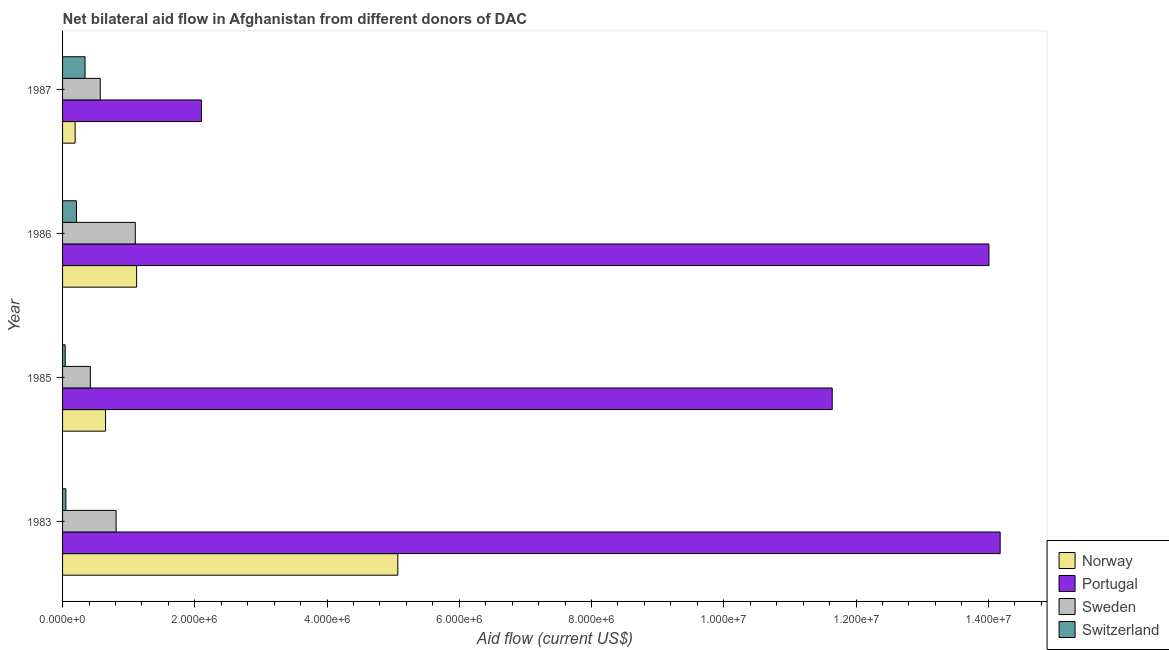How many groups of bars are there?
Provide a succinct answer. 4. Are the number of bars per tick equal to the number of legend labels?
Give a very brief answer. Yes. How many bars are there on the 4th tick from the bottom?
Your response must be concise. 4. What is the label of the 2nd group of bars from the top?
Your answer should be compact. 1986. What is the amount of aid given by sweden in 1983?
Provide a succinct answer. 8.10e+05. Across all years, what is the maximum amount of aid given by switzerland?
Offer a terse response. 3.40e+05. Across all years, what is the minimum amount of aid given by switzerland?
Offer a terse response. 4.00e+04. What is the total amount of aid given by portugal in the graph?
Give a very brief answer. 4.19e+07. What is the difference between the amount of aid given by portugal in 1985 and that in 1986?
Provide a short and direct response. -2.37e+06. What is the difference between the amount of aid given by sweden in 1985 and the amount of aid given by norway in 1986?
Ensure brevity in your answer.  -7.00e+05. What is the average amount of aid given by sweden per year?
Offer a very short reply. 7.25e+05. In the year 1985, what is the difference between the amount of aid given by norway and amount of aid given by switzerland?
Provide a succinct answer. 6.10e+05. In how many years, is the amount of aid given by portugal greater than 2400000 US$?
Offer a very short reply. 3. What is the ratio of the amount of aid given by portugal in 1985 to that in 1987?
Provide a succinct answer. 5.54. What is the difference between the highest and the second highest amount of aid given by portugal?
Provide a succinct answer. 1.70e+05. What is the difference between the highest and the lowest amount of aid given by sweden?
Provide a short and direct response. 6.80e+05. In how many years, is the amount of aid given by sweden greater than the average amount of aid given by sweden taken over all years?
Make the answer very short. 2. Is the sum of the amount of aid given by switzerland in 1985 and 1987 greater than the maximum amount of aid given by portugal across all years?
Provide a short and direct response. No. What does the 1st bar from the top in 1987 represents?
Offer a very short reply. Switzerland. What does the 1st bar from the bottom in 1983 represents?
Ensure brevity in your answer.  Norway. Is it the case that in every year, the sum of the amount of aid given by norway and amount of aid given by portugal is greater than the amount of aid given by sweden?
Offer a terse response. Yes. How many bars are there?
Provide a short and direct response. 16. How many years are there in the graph?
Provide a succinct answer. 4. What is the difference between two consecutive major ticks on the X-axis?
Provide a succinct answer. 2.00e+06. Where does the legend appear in the graph?
Your response must be concise. Bottom right. What is the title of the graph?
Ensure brevity in your answer.  Net bilateral aid flow in Afghanistan from different donors of DAC. What is the label or title of the X-axis?
Give a very brief answer. Aid flow (current US$). What is the Aid flow (current US$) in Norway in 1983?
Make the answer very short. 5.07e+06. What is the Aid flow (current US$) in Portugal in 1983?
Offer a very short reply. 1.42e+07. What is the Aid flow (current US$) of Sweden in 1983?
Your answer should be compact. 8.10e+05. What is the Aid flow (current US$) in Norway in 1985?
Provide a short and direct response. 6.50e+05. What is the Aid flow (current US$) of Portugal in 1985?
Offer a terse response. 1.16e+07. What is the Aid flow (current US$) in Sweden in 1985?
Make the answer very short. 4.20e+05. What is the Aid flow (current US$) in Norway in 1986?
Make the answer very short. 1.12e+06. What is the Aid flow (current US$) of Portugal in 1986?
Ensure brevity in your answer.  1.40e+07. What is the Aid flow (current US$) in Sweden in 1986?
Your response must be concise. 1.10e+06. What is the Aid flow (current US$) in Switzerland in 1986?
Offer a terse response. 2.10e+05. What is the Aid flow (current US$) in Portugal in 1987?
Keep it short and to the point. 2.10e+06. What is the Aid flow (current US$) in Sweden in 1987?
Ensure brevity in your answer.  5.70e+05. Across all years, what is the maximum Aid flow (current US$) in Norway?
Ensure brevity in your answer.  5.07e+06. Across all years, what is the maximum Aid flow (current US$) in Portugal?
Provide a short and direct response. 1.42e+07. Across all years, what is the maximum Aid flow (current US$) of Sweden?
Your response must be concise. 1.10e+06. Across all years, what is the maximum Aid flow (current US$) in Switzerland?
Keep it short and to the point. 3.40e+05. Across all years, what is the minimum Aid flow (current US$) of Norway?
Make the answer very short. 1.90e+05. Across all years, what is the minimum Aid flow (current US$) of Portugal?
Provide a short and direct response. 2.10e+06. Across all years, what is the minimum Aid flow (current US$) in Sweden?
Offer a very short reply. 4.20e+05. What is the total Aid flow (current US$) in Norway in the graph?
Your answer should be compact. 7.03e+06. What is the total Aid flow (current US$) of Portugal in the graph?
Offer a very short reply. 4.19e+07. What is the total Aid flow (current US$) in Sweden in the graph?
Provide a short and direct response. 2.90e+06. What is the total Aid flow (current US$) in Switzerland in the graph?
Provide a succinct answer. 6.40e+05. What is the difference between the Aid flow (current US$) in Norway in 1983 and that in 1985?
Your answer should be very brief. 4.42e+06. What is the difference between the Aid flow (current US$) in Portugal in 1983 and that in 1985?
Ensure brevity in your answer.  2.54e+06. What is the difference between the Aid flow (current US$) of Norway in 1983 and that in 1986?
Your answer should be compact. 3.95e+06. What is the difference between the Aid flow (current US$) in Sweden in 1983 and that in 1986?
Provide a short and direct response. -2.90e+05. What is the difference between the Aid flow (current US$) of Norway in 1983 and that in 1987?
Provide a short and direct response. 4.88e+06. What is the difference between the Aid flow (current US$) in Portugal in 1983 and that in 1987?
Give a very brief answer. 1.21e+07. What is the difference between the Aid flow (current US$) of Norway in 1985 and that in 1986?
Ensure brevity in your answer.  -4.70e+05. What is the difference between the Aid flow (current US$) of Portugal in 1985 and that in 1986?
Your answer should be compact. -2.37e+06. What is the difference between the Aid flow (current US$) in Sweden in 1985 and that in 1986?
Keep it short and to the point. -6.80e+05. What is the difference between the Aid flow (current US$) of Switzerland in 1985 and that in 1986?
Keep it short and to the point. -1.70e+05. What is the difference between the Aid flow (current US$) in Portugal in 1985 and that in 1987?
Make the answer very short. 9.54e+06. What is the difference between the Aid flow (current US$) in Sweden in 1985 and that in 1987?
Keep it short and to the point. -1.50e+05. What is the difference between the Aid flow (current US$) in Norway in 1986 and that in 1987?
Your answer should be compact. 9.30e+05. What is the difference between the Aid flow (current US$) in Portugal in 1986 and that in 1987?
Your response must be concise. 1.19e+07. What is the difference between the Aid flow (current US$) in Sweden in 1986 and that in 1987?
Offer a terse response. 5.30e+05. What is the difference between the Aid flow (current US$) in Norway in 1983 and the Aid flow (current US$) in Portugal in 1985?
Your answer should be very brief. -6.57e+06. What is the difference between the Aid flow (current US$) of Norway in 1983 and the Aid flow (current US$) of Sweden in 1985?
Offer a very short reply. 4.65e+06. What is the difference between the Aid flow (current US$) of Norway in 1983 and the Aid flow (current US$) of Switzerland in 1985?
Offer a terse response. 5.03e+06. What is the difference between the Aid flow (current US$) of Portugal in 1983 and the Aid flow (current US$) of Sweden in 1985?
Offer a very short reply. 1.38e+07. What is the difference between the Aid flow (current US$) of Portugal in 1983 and the Aid flow (current US$) of Switzerland in 1985?
Offer a very short reply. 1.41e+07. What is the difference between the Aid flow (current US$) in Sweden in 1983 and the Aid flow (current US$) in Switzerland in 1985?
Your response must be concise. 7.70e+05. What is the difference between the Aid flow (current US$) of Norway in 1983 and the Aid flow (current US$) of Portugal in 1986?
Provide a short and direct response. -8.94e+06. What is the difference between the Aid flow (current US$) in Norway in 1983 and the Aid flow (current US$) in Sweden in 1986?
Make the answer very short. 3.97e+06. What is the difference between the Aid flow (current US$) in Norway in 1983 and the Aid flow (current US$) in Switzerland in 1986?
Make the answer very short. 4.86e+06. What is the difference between the Aid flow (current US$) of Portugal in 1983 and the Aid flow (current US$) of Sweden in 1986?
Keep it short and to the point. 1.31e+07. What is the difference between the Aid flow (current US$) in Portugal in 1983 and the Aid flow (current US$) in Switzerland in 1986?
Offer a very short reply. 1.40e+07. What is the difference between the Aid flow (current US$) of Sweden in 1983 and the Aid flow (current US$) of Switzerland in 1986?
Offer a very short reply. 6.00e+05. What is the difference between the Aid flow (current US$) in Norway in 1983 and the Aid flow (current US$) in Portugal in 1987?
Make the answer very short. 2.97e+06. What is the difference between the Aid flow (current US$) of Norway in 1983 and the Aid flow (current US$) of Sweden in 1987?
Offer a very short reply. 4.50e+06. What is the difference between the Aid flow (current US$) of Norway in 1983 and the Aid flow (current US$) of Switzerland in 1987?
Offer a terse response. 4.73e+06. What is the difference between the Aid flow (current US$) in Portugal in 1983 and the Aid flow (current US$) in Sweden in 1987?
Make the answer very short. 1.36e+07. What is the difference between the Aid flow (current US$) in Portugal in 1983 and the Aid flow (current US$) in Switzerland in 1987?
Keep it short and to the point. 1.38e+07. What is the difference between the Aid flow (current US$) of Sweden in 1983 and the Aid flow (current US$) of Switzerland in 1987?
Ensure brevity in your answer.  4.70e+05. What is the difference between the Aid flow (current US$) of Norway in 1985 and the Aid flow (current US$) of Portugal in 1986?
Your answer should be compact. -1.34e+07. What is the difference between the Aid flow (current US$) in Norway in 1985 and the Aid flow (current US$) in Sweden in 1986?
Keep it short and to the point. -4.50e+05. What is the difference between the Aid flow (current US$) in Portugal in 1985 and the Aid flow (current US$) in Sweden in 1986?
Provide a succinct answer. 1.05e+07. What is the difference between the Aid flow (current US$) in Portugal in 1985 and the Aid flow (current US$) in Switzerland in 1986?
Keep it short and to the point. 1.14e+07. What is the difference between the Aid flow (current US$) in Sweden in 1985 and the Aid flow (current US$) in Switzerland in 1986?
Make the answer very short. 2.10e+05. What is the difference between the Aid flow (current US$) of Norway in 1985 and the Aid flow (current US$) of Portugal in 1987?
Ensure brevity in your answer.  -1.45e+06. What is the difference between the Aid flow (current US$) of Portugal in 1985 and the Aid flow (current US$) of Sweden in 1987?
Offer a terse response. 1.11e+07. What is the difference between the Aid flow (current US$) in Portugal in 1985 and the Aid flow (current US$) in Switzerland in 1987?
Provide a succinct answer. 1.13e+07. What is the difference between the Aid flow (current US$) in Norway in 1986 and the Aid flow (current US$) in Portugal in 1987?
Give a very brief answer. -9.80e+05. What is the difference between the Aid flow (current US$) of Norway in 1986 and the Aid flow (current US$) of Switzerland in 1987?
Ensure brevity in your answer.  7.80e+05. What is the difference between the Aid flow (current US$) in Portugal in 1986 and the Aid flow (current US$) in Sweden in 1987?
Provide a short and direct response. 1.34e+07. What is the difference between the Aid flow (current US$) in Portugal in 1986 and the Aid flow (current US$) in Switzerland in 1987?
Give a very brief answer. 1.37e+07. What is the difference between the Aid flow (current US$) of Sweden in 1986 and the Aid flow (current US$) of Switzerland in 1987?
Keep it short and to the point. 7.60e+05. What is the average Aid flow (current US$) of Norway per year?
Keep it short and to the point. 1.76e+06. What is the average Aid flow (current US$) in Portugal per year?
Your answer should be very brief. 1.05e+07. What is the average Aid flow (current US$) of Sweden per year?
Provide a short and direct response. 7.25e+05. What is the average Aid flow (current US$) in Switzerland per year?
Offer a very short reply. 1.60e+05. In the year 1983, what is the difference between the Aid flow (current US$) in Norway and Aid flow (current US$) in Portugal?
Provide a short and direct response. -9.11e+06. In the year 1983, what is the difference between the Aid flow (current US$) in Norway and Aid flow (current US$) in Sweden?
Keep it short and to the point. 4.26e+06. In the year 1983, what is the difference between the Aid flow (current US$) of Norway and Aid flow (current US$) of Switzerland?
Make the answer very short. 5.02e+06. In the year 1983, what is the difference between the Aid flow (current US$) in Portugal and Aid flow (current US$) in Sweden?
Your answer should be compact. 1.34e+07. In the year 1983, what is the difference between the Aid flow (current US$) in Portugal and Aid flow (current US$) in Switzerland?
Ensure brevity in your answer.  1.41e+07. In the year 1983, what is the difference between the Aid flow (current US$) in Sweden and Aid flow (current US$) in Switzerland?
Keep it short and to the point. 7.60e+05. In the year 1985, what is the difference between the Aid flow (current US$) of Norway and Aid flow (current US$) of Portugal?
Offer a very short reply. -1.10e+07. In the year 1985, what is the difference between the Aid flow (current US$) of Portugal and Aid flow (current US$) of Sweden?
Make the answer very short. 1.12e+07. In the year 1985, what is the difference between the Aid flow (current US$) in Portugal and Aid flow (current US$) in Switzerland?
Keep it short and to the point. 1.16e+07. In the year 1986, what is the difference between the Aid flow (current US$) in Norway and Aid flow (current US$) in Portugal?
Your answer should be very brief. -1.29e+07. In the year 1986, what is the difference between the Aid flow (current US$) of Norway and Aid flow (current US$) of Switzerland?
Provide a short and direct response. 9.10e+05. In the year 1986, what is the difference between the Aid flow (current US$) in Portugal and Aid flow (current US$) in Sweden?
Give a very brief answer. 1.29e+07. In the year 1986, what is the difference between the Aid flow (current US$) of Portugal and Aid flow (current US$) of Switzerland?
Your answer should be compact. 1.38e+07. In the year 1986, what is the difference between the Aid flow (current US$) in Sweden and Aid flow (current US$) in Switzerland?
Give a very brief answer. 8.90e+05. In the year 1987, what is the difference between the Aid flow (current US$) in Norway and Aid flow (current US$) in Portugal?
Offer a terse response. -1.91e+06. In the year 1987, what is the difference between the Aid flow (current US$) in Norway and Aid flow (current US$) in Sweden?
Give a very brief answer. -3.80e+05. In the year 1987, what is the difference between the Aid flow (current US$) in Norway and Aid flow (current US$) in Switzerland?
Your response must be concise. -1.50e+05. In the year 1987, what is the difference between the Aid flow (current US$) in Portugal and Aid flow (current US$) in Sweden?
Keep it short and to the point. 1.53e+06. In the year 1987, what is the difference between the Aid flow (current US$) in Portugal and Aid flow (current US$) in Switzerland?
Provide a short and direct response. 1.76e+06. In the year 1987, what is the difference between the Aid flow (current US$) in Sweden and Aid flow (current US$) in Switzerland?
Your answer should be very brief. 2.30e+05. What is the ratio of the Aid flow (current US$) in Norway in 1983 to that in 1985?
Ensure brevity in your answer.  7.8. What is the ratio of the Aid flow (current US$) of Portugal in 1983 to that in 1985?
Ensure brevity in your answer.  1.22. What is the ratio of the Aid flow (current US$) of Sweden in 1983 to that in 1985?
Make the answer very short. 1.93. What is the ratio of the Aid flow (current US$) in Norway in 1983 to that in 1986?
Keep it short and to the point. 4.53. What is the ratio of the Aid flow (current US$) in Portugal in 1983 to that in 1986?
Make the answer very short. 1.01. What is the ratio of the Aid flow (current US$) of Sweden in 1983 to that in 1986?
Keep it short and to the point. 0.74. What is the ratio of the Aid flow (current US$) of Switzerland in 1983 to that in 1986?
Make the answer very short. 0.24. What is the ratio of the Aid flow (current US$) of Norway in 1983 to that in 1987?
Your answer should be compact. 26.68. What is the ratio of the Aid flow (current US$) of Portugal in 1983 to that in 1987?
Ensure brevity in your answer.  6.75. What is the ratio of the Aid flow (current US$) of Sweden in 1983 to that in 1987?
Your answer should be compact. 1.42. What is the ratio of the Aid flow (current US$) in Switzerland in 1983 to that in 1987?
Make the answer very short. 0.15. What is the ratio of the Aid flow (current US$) of Norway in 1985 to that in 1986?
Your answer should be compact. 0.58. What is the ratio of the Aid flow (current US$) of Portugal in 1985 to that in 1986?
Your answer should be compact. 0.83. What is the ratio of the Aid flow (current US$) of Sweden in 1985 to that in 1986?
Ensure brevity in your answer.  0.38. What is the ratio of the Aid flow (current US$) of Switzerland in 1985 to that in 1986?
Your answer should be compact. 0.19. What is the ratio of the Aid flow (current US$) in Norway in 1985 to that in 1987?
Give a very brief answer. 3.42. What is the ratio of the Aid flow (current US$) of Portugal in 1985 to that in 1987?
Provide a short and direct response. 5.54. What is the ratio of the Aid flow (current US$) in Sweden in 1985 to that in 1987?
Make the answer very short. 0.74. What is the ratio of the Aid flow (current US$) of Switzerland in 1985 to that in 1987?
Ensure brevity in your answer.  0.12. What is the ratio of the Aid flow (current US$) of Norway in 1986 to that in 1987?
Ensure brevity in your answer.  5.89. What is the ratio of the Aid flow (current US$) in Portugal in 1986 to that in 1987?
Your answer should be compact. 6.67. What is the ratio of the Aid flow (current US$) of Sweden in 1986 to that in 1987?
Keep it short and to the point. 1.93. What is the ratio of the Aid flow (current US$) in Switzerland in 1986 to that in 1987?
Your answer should be very brief. 0.62. What is the difference between the highest and the second highest Aid flow (current US$) in Norway?
Offer a terse response. 3.95e+06. What is the difference between the highest and the lowest Aid flow (current US$) of Norway?
Keep it short and to the point. 4.88e+06. What is the difference between the highest and the lowest Aid flow (current US$) in Portugal?
Keep it short and to the point. 1.21e+07. What is the difference between the highest and the lowest Aid flow (current US$) in Sweden?
Your answer should be compact. 6.80e+05. What is the difference between the highest and the lowest Aid flow (current US$) of Switzerland?
Your answer should be compact. 3.00e+05. 